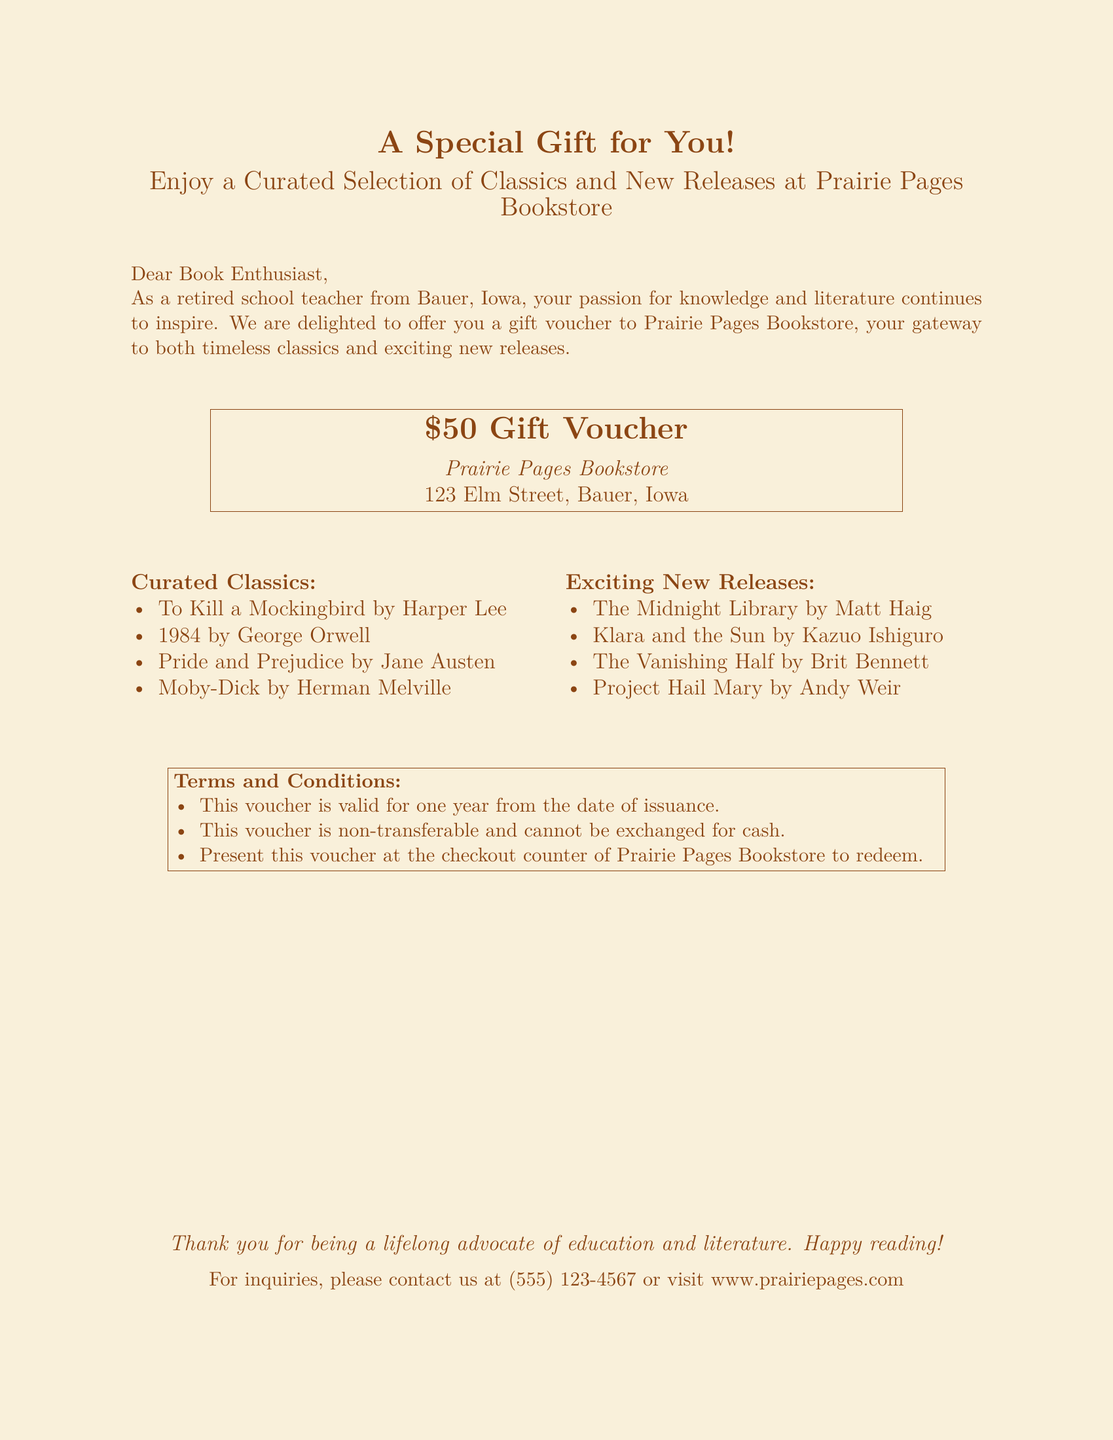What is the value of the gift voucher? The document explicitly states the amount of the gift voucher offered to the recipient.
Answer: $50 What is the name of the bookstore? The name of the bookstore where the gift voucher is valid is provided in the document.
Answer: Prairie Pages Bookstore Where is Prairie Pages Bookstore located? The document provides the address of the bookstore.
Answer: 123 Elm Street, Bauer, Iowa How long is the voucher valid? The document mentions the validity period of the voucher in terms of time from issuance.
Answer: One year Can the voucher be exchanged for cash? The terms and conditions in the document specify whether the voucher can be exchanged for cash.
Answer: No Which author wrote "Pride and Prejudice"? The document lists various classics and the author of "Pride and Prejudice" is included.
Answer: Jane Austen What genre do the listed "Exciting New Releases" belong to? By looking at the context, the voucher indicates the type of selections included in the document.
Answer: New Releases Is the voucher transferable? The terms listed in the document clarify the nature of the voucher's transferability.
Answer: No 